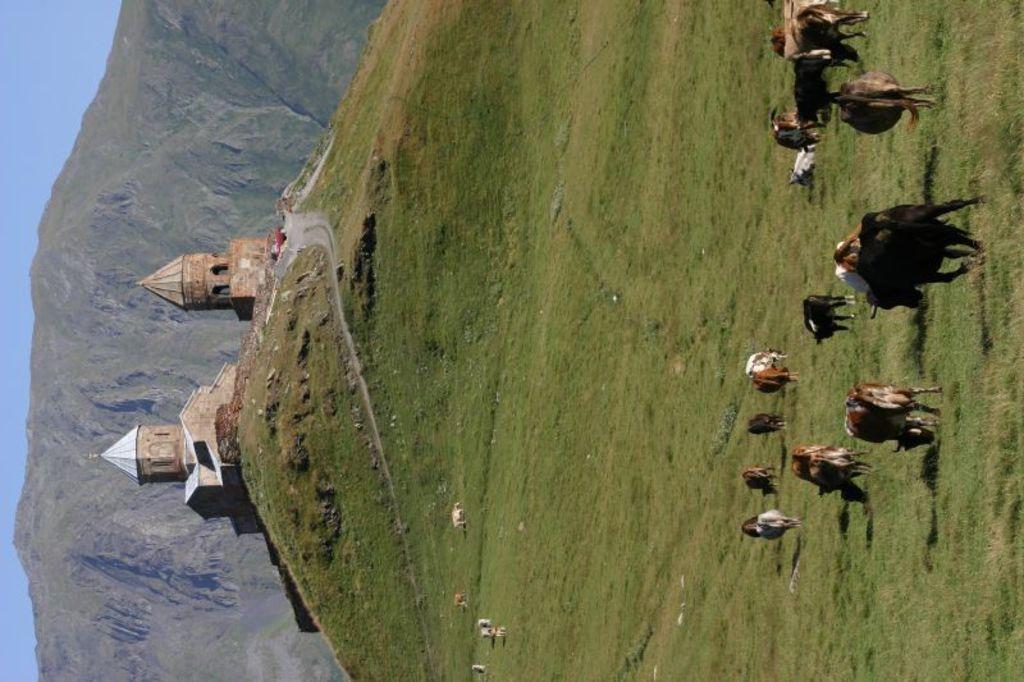Describe this image in one or two sentences. In this image we can see a group of cow eating the grass. Here we can see the house on the left side. Here we can see the mountains. 